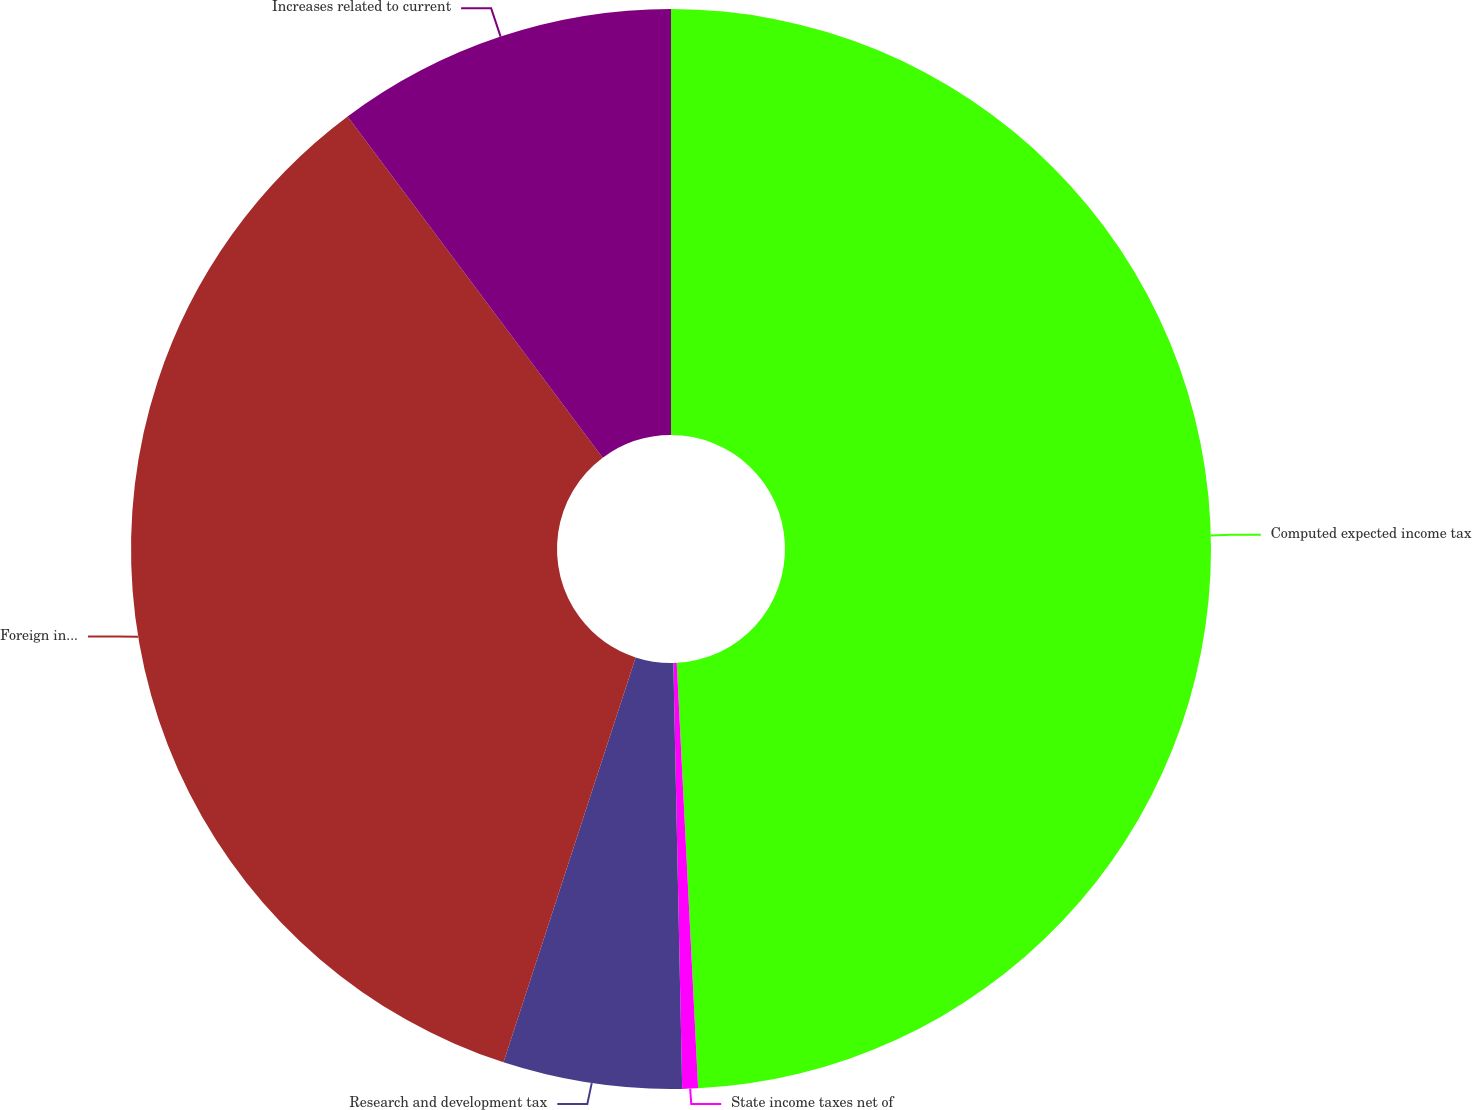Convert chart to OTSL. <chart><loc_0><loc_0><loc_500><loc_500><pie_chart><fcel>Computed expected income tax<fcel>State income taxes net of<fcel>Research and development tax<fcel>Foreign income taxed at lower<fcel>Increases related to current<nl><fcel>49.2%<fcel>0.47%<fcel>5.35%<fcel>34.76%<fcel>10.22%<nl></chart> 